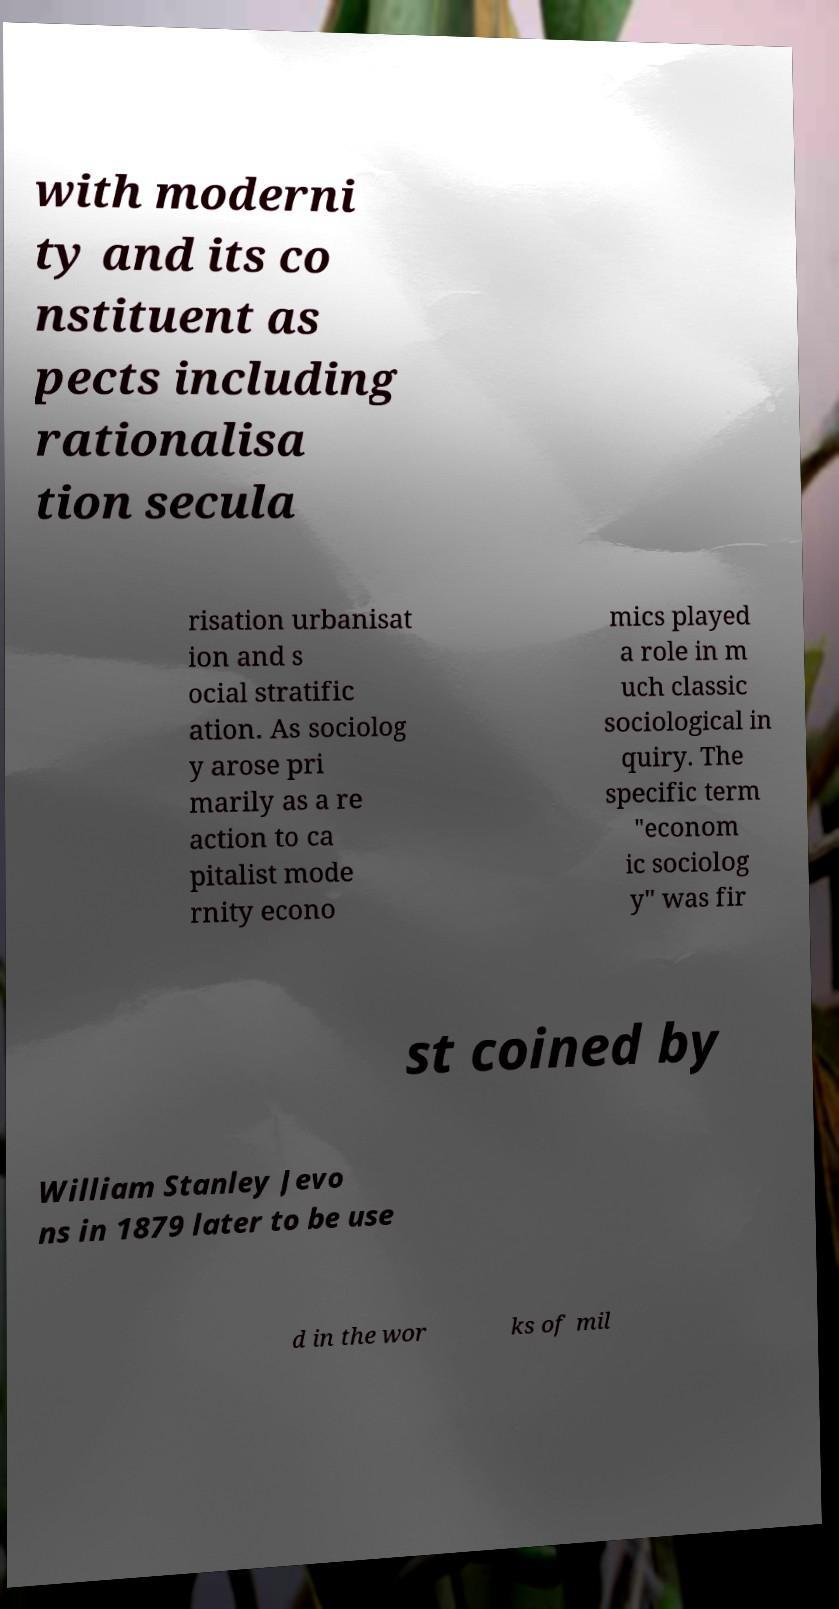Please identify and transcribe the text found in this image. with moderni ty and its co nstituent as pects including rationalisa tion secula risation urbanisat ion and s ocial stratific ation. As sociolog y arose pri marily as a re action to ca pitalist mode rnity econo mics played a role in m uch classic sociological in quiry. The specific term "econom ic sociolog y" was fir st coined by William Stanley Jevo ns in 1879 later to be use d in the wor ks of mil 